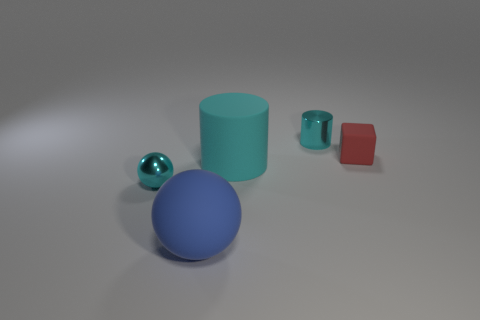Is there any other thing that is the same shape as the red thing?
Provide a short and direct response. No. What is the color of the small block that is made of the same material as the big sphere?
Offer a terse response. Red. There is a rubber thing on the right side of the tiny cyan thing that is behind the tiny red cube; is there a tiny red matte object right of it?
Offer a terse response. No. Are there fewer tiny red cubes that are in front of the large blue thing than cyan cylinders behind the tiny sphere?
Your answer should be compact. Yes. What number of blue things are the same material as the tiny cyan sphere?
Make the answer very short. 0. Is the size of the blue rubber object the same as the thing left of the large blue ball?
Offer a terse response. No. There is a tiny cylinder that is the same color as the metal ball; what material is it?
Provide a succinct answer. Metal. There is a shiny object in front of the cyan shiny object on the right side of the small cyan shiny thing that is in front of the large cyan matte thing; what is its size?
Provide a short and direct response. Small. Is the number of small matte objects left of the cyan sphere greater than the number of matte spheres to the left of the cyan matte cylinder?
Offer a very short reply. No. There is a cyan cylinder that is behind the large cyan cylinder; how many tiny rubber things are behind it?
Your response must be concise. 0. 